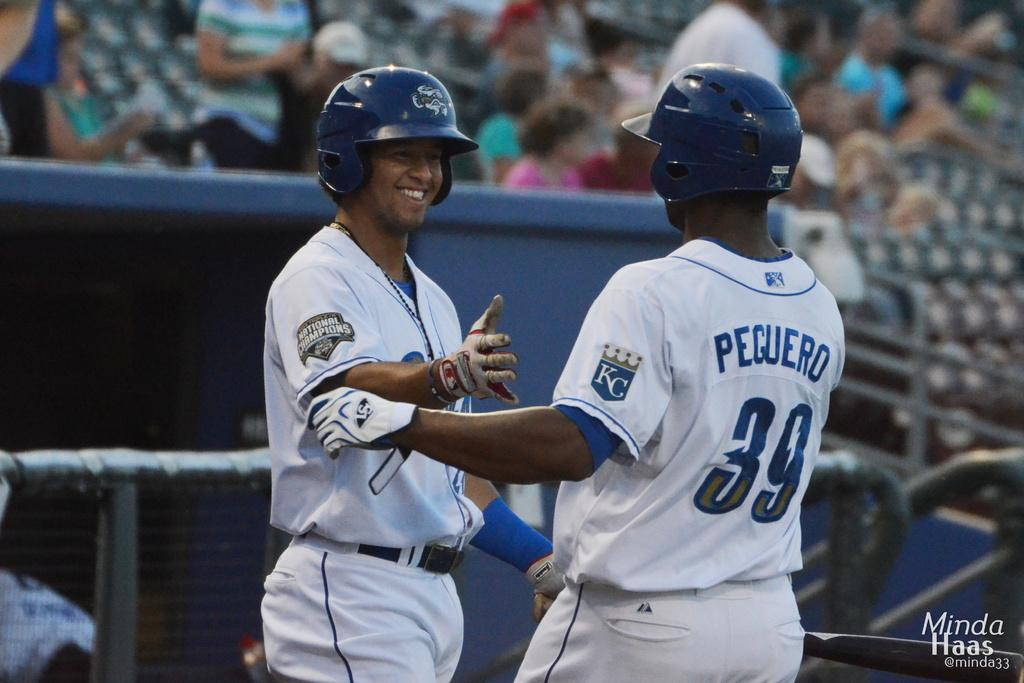How many men are present in the image? There are two men standing in the image. What can be seen in the background of the image? There is a fence and a group of people visible in the background of the image. What might be used for seating in the image? There are empty chairs in the background of the image. What type of news can be heard coming from the guide in the image? There is no guide or news present in the image. 